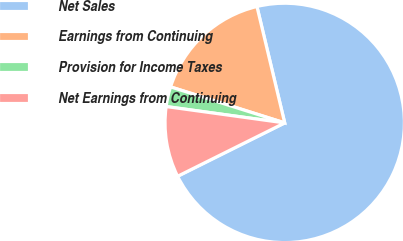Convert chart. <chart><loc_0><loc_0><loc_500><loc_500><pie_chart><fcel>Net Sales<fcel>Earnings from Continuing<fcel>Provision for Income Taxes<fcel>Net Earnings from Continuing<nl><fcel>71.37%<fcel>16.41%<fcel>2.68%<fcel>9.54%<nl></chart> 